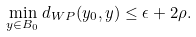<formula> <loc_0><loc_0><loc_500><loc_500>\min _ { y \in B _ { 0 } } d _ { W P } ( y _ { 0 } , y ) \leq \epsilon + 2 \rho .</formula> 